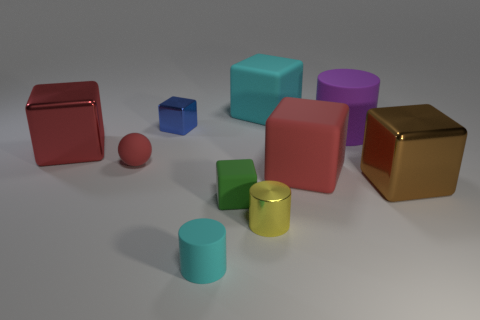Do the purple object and the blue thing have the same size?
Give a very brief answer. No. Do the metallic thing that is on the right side of the purple rubber thing and the small matte cylinder have the same color?
Offer a very short reply. No. There is a cyan matte object that is in front of the matte block that is behind the blue object; what is its shape?
Offer a terse response. Cylinder. The tiny metal object that is in front of the cylinder behind the red block that is behind the small red ball is what shape?
Your answer should be very brief. Cylinder. Are there fewer brown cubes on the right side of the small blue metallic thing than tiny red matte spheres?
Your response must be concise. No. What color is the big matte thing behind the rubber cylinder behind the large red object that is left of the cyan matte cube?
Offer a terse response. Cyan. What is the size of the cyan object that is the same shape as the red metallic object?
Provide a succinct answer. Large. Is the number of big red rubber things that are behind the yellow cylinder less than the number of cylinders right of the small cyan cylinder?
Offer a very short reply. Yes. There is a matte object that is both behind the red matte block and left of the tiny yellow shiny object; what shape is it?
Your answer should be compact. Sphere. The red block that is made of the same material as the yellow thing is what size?
Keep it short and to the point. Large. 